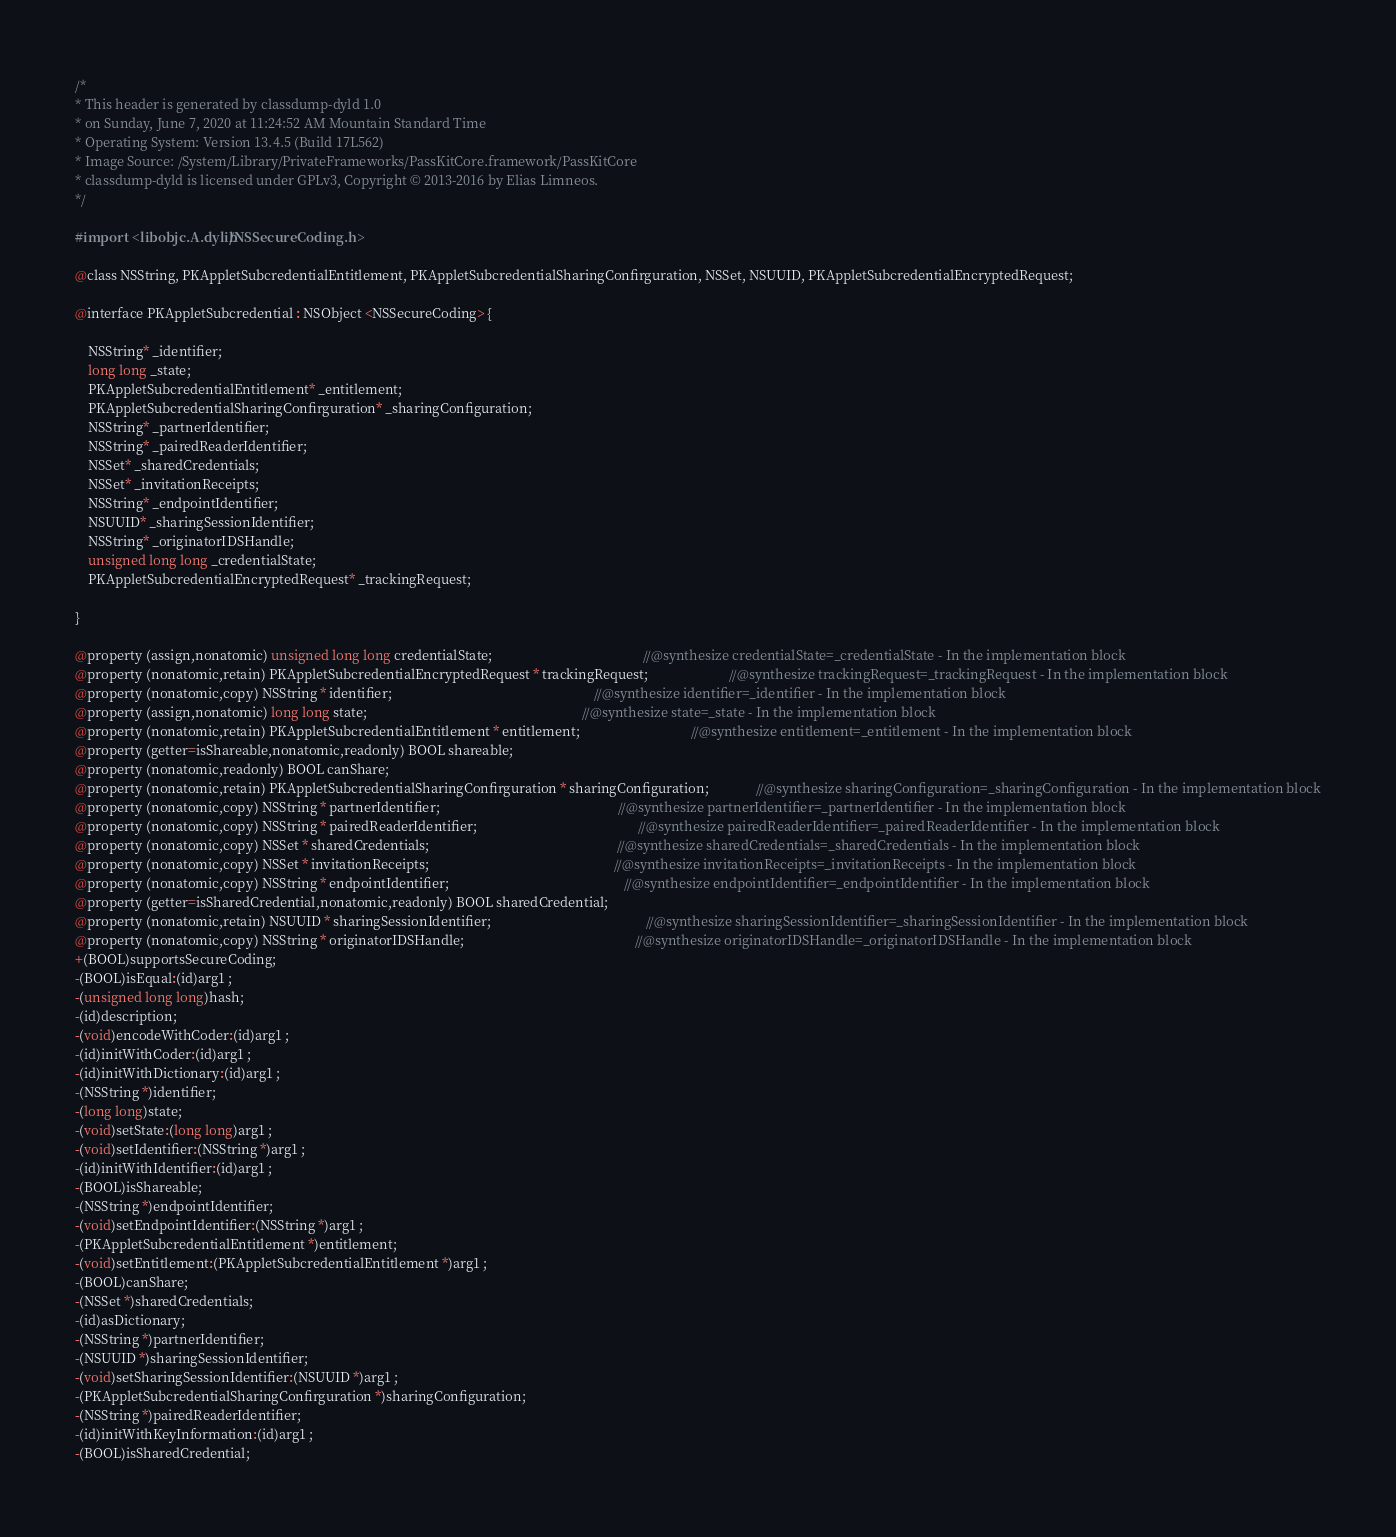Convert code to text. <code><loc_0><loc_0><loc_500><loc_500><_C_>/*
* This header is generated by classdump-dyld 1.0
* on Sunday, June 7, 2020 at 11:24:52 AM Mountain Standard Time
* Operating System: Version 13.4.5 (Build 17L562)
* Image Source: /System/Library/PrivateFrameworks/PassKitCore.framework/PassKitCore
* classdump-dyld is licensed under GPLv3, Copyright © 2013-2016 by Elias Limneos.
*/

#import <libobjc.A.dylib/NSSecureCoding.h>

@class NSString, PKAppletSubcredentialEntitlement, PKAppletSubcredentialSharingConfirguration, NSSet, NSUUID, PKAppletSubcredentialEncryptedRequest;

@interface PKAppletSubcredential : NSObject <NSSecureCoding> {

	NSString* _identifier;
	long long _state;
	PKAppletSubcredentialEntitlement* _entitlement;
	PKAppletSubcredentialSharingConfirguration* _sharingConfiguration;
	NSString* _partnerIdentifier;
	NSString* _pairedReaderIdentifier;
	NSSet* _sharedCredentials;
	NSSet* _invitationReceipts;
	NSString* _endpointIdentifier;
	NSUUID* _sharingSessionIdentifier;
	NSString* _originatorIDSHandle;
	unsigned long long _credentialState;
	PKAppletSubcredentialEncryptedRequest* _trackingRequest;

}

@property (assign,nonatomic) unsigned long long credentialState;                                             //@synthesize credentialState=_credentialState - In the implementation block
@property (nonatomic,retain) PKAppletSubcredentialEncryptedRequest * trackingRequest;                        //@synthesize trackingRequest=_trackingRequest - In the implementation block
@property (nonatomic,copy) NSString * identifier;                                                            //@synthesize identifier=_identifier - In the implementation block
@property (assign,nonatomic) long long state;                                                                //@synthesize state=_state - In the implementation block
@property (nonatomic,retain) PKAppletSubcredentialEntitlement * entitlement;                                 //@synthesize entitlement=_entitlement - In the implementation block
@property (getter=isShareable,nonatomic,readonly) BOOL shareable; 
@property (nonatomic,readonly) BOOL canShare; 
@property (nonatomic,retain) PKAppletSubcredentialSharingConfirguration * sharingConfiguration;              //@synthesize sharingConfiguration=_sharingConfiguration - In the implementation block
@property (nonatomic,copy) NSString * partnerIdentifier;                                                     //@synthesize partnerIdentifier=_partnerIdentifier - In the implementation block
@property (nonatomic,copy) NSString * pairedReaderIdentifier;                                                //@synthesize pairedReaderIdentifier=_pairedReaderIdentifier - In the implementation block
@property (nonatomic,copy) NSSet * sharedCredentials;                                                        //@synthesize sharedCredentials=_sharedCredentials - In the implementation block
@property (nonatomic,copy) NSSet * invitationReceipts;                                                       //@synthesize invitationReceipts=_invitationReceipts - In the implementation block
@property (nonatomic,copy) NSString * endpointIdentifier;                                                    //@synthesize endpointIdentifier=_endpointIdentifier - In the implementation block
@property (getter=isSharedCredential,nonatomic,readonly) BOOL sharedCredential; 
@property (nonatomic,retain) NSUUID * sharingSessionIdentifier;                                              //@synthesize sharingSessionIdentifier=_sharingSessionIdentifier - In the implementation block
@property (nonatomic,copy) NSString * originatorIDSHandle;                                                   //@synthesize originatorIDSHandle=_originatorIDSHandle - In the implementation block
+(BOOL)supportsSecureCoding;
-(BOOL)isEqual:(id)arg1 ;
-(unsigned long long)hash;
-(id)description;
-(void)encodeWithCoder:(id)arg1 ;
-(id)initWithCoder:(id)arg1 ;
-(id)initWithDictionary:(id)arg1 ;
-(NSString *)identifier;
-(long long)state;
-(void)setState:(long long)arg1 ;
-(void)setIdentifier:(NSString *)arg1 ;
-(id)initWithIdentifier:(id)arg1 ;
-(BOOL)isShareable;
-(NSString *)endpointIdentifier;
-(void)setEndpointIdentifier:(NSString *)arg1 ;
-(PKAppletSubcredentialEntitlement *)entitlement;
-(void)setEntitlement:(PKAppletSubcredentialEntitlement *)arg1 ;
-(BOOL)canShare;
-(NSSet *)sharedCredentials;
-(id)asDictionary;
-(NSString *)partnerIdentifier;
-(NSUUID *)sharingSessionIdentifier;
-(void)setSharingSessionIdentifier:(NSUUID *)arg1 ;
-(PKAppletSubcredentialSharingConfirguration *)sharingConfiguration;
-(NSString *)pairedReaderIdentifier;
-(id)initWithKeyInformation:(id)arg1 ;
-(BOOL)isSharedCredential;</code> 